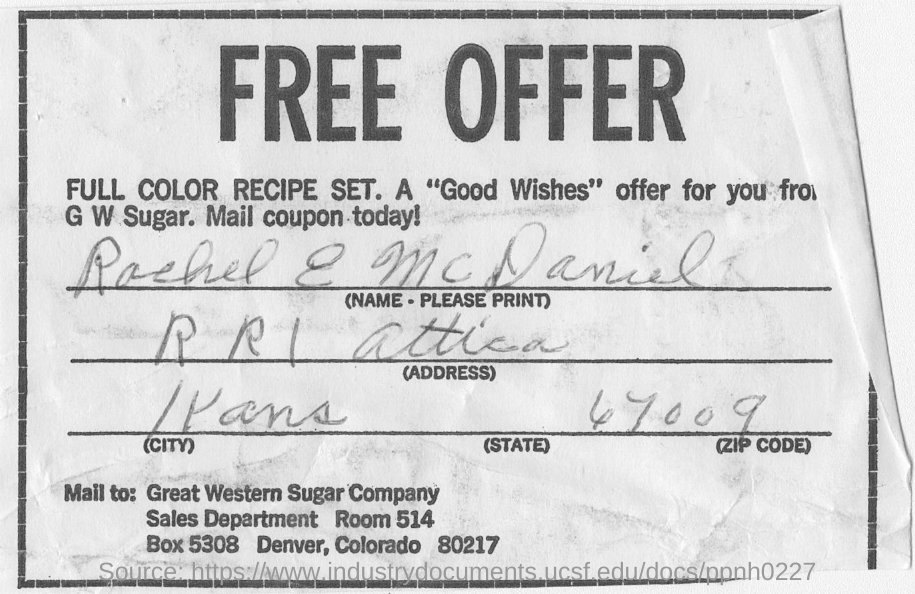Point out several critical features in this image. The form was filled by RACHEL E MCDANIEL. The "Good Wishes" offer is from G W Sugar. The zip code handwritten on the form is 67009. 